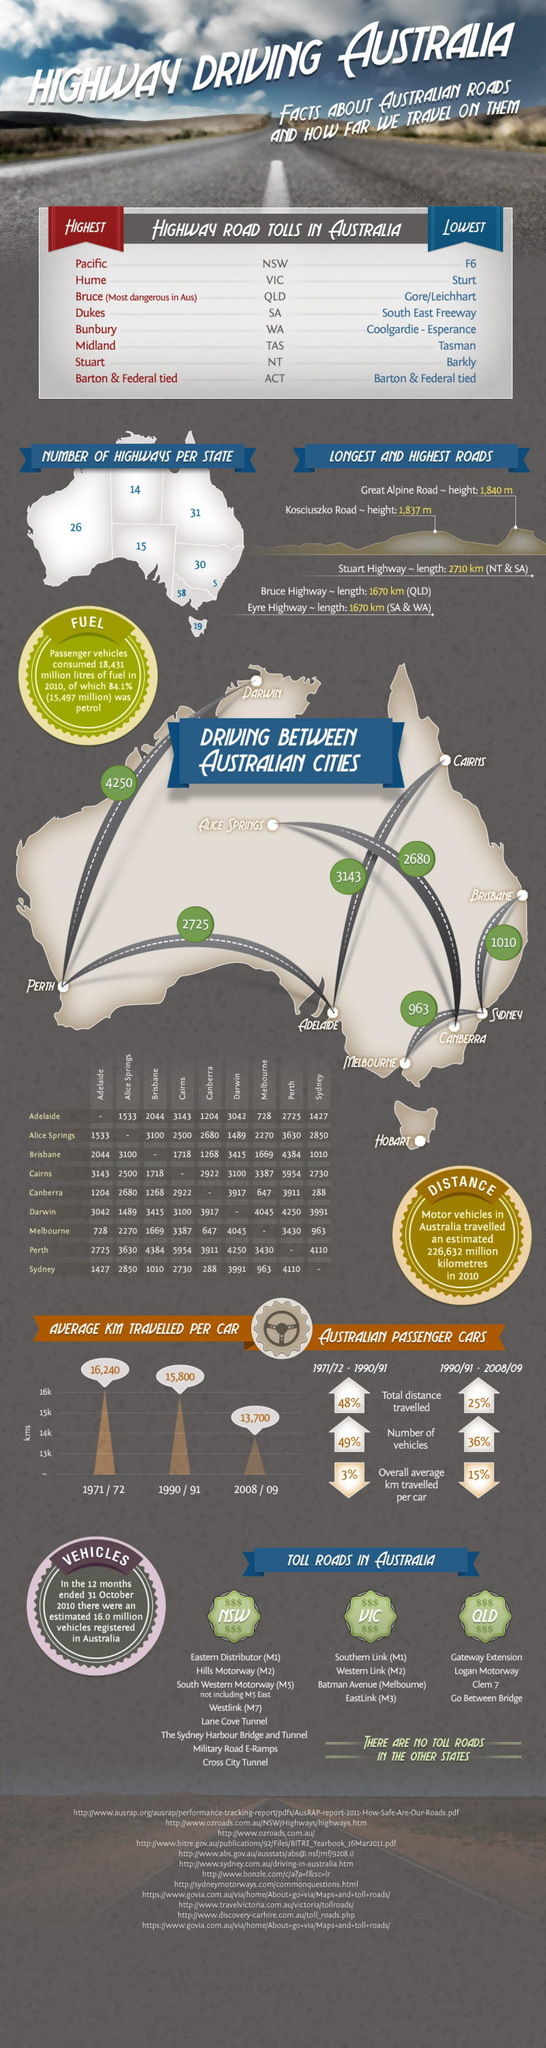How many highways are there in the state or province of Tasmania?
Answer the question with a short phrase. 19 Which state or province has the most number of toll roads, Victoria, Queensland, or New South Wales? New South Wales How many highways are there in the state or province of Queensland? 31 Which is the longest distance in kms between two cities in Australia? 5954 How many highways are there in the state or province of Victoria? 58 What is the distance between Cairns and Adelaide? 3143 Which is the longest highway that falls in South and Western Australia? Eyre Highway 